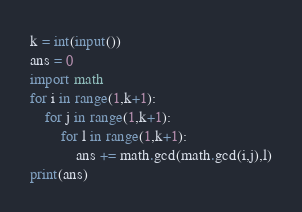<code> <loc_0><loc_0><loc_500><loc_500><_Python_>k = int(input())
ans = 0
import math
for i in range(1,k+1):
    for j in range(1,k+1):
        for l in range(1,k+1):
            ans += math.gcd(math.gcd(i,j),l)
print(ans)</code> 